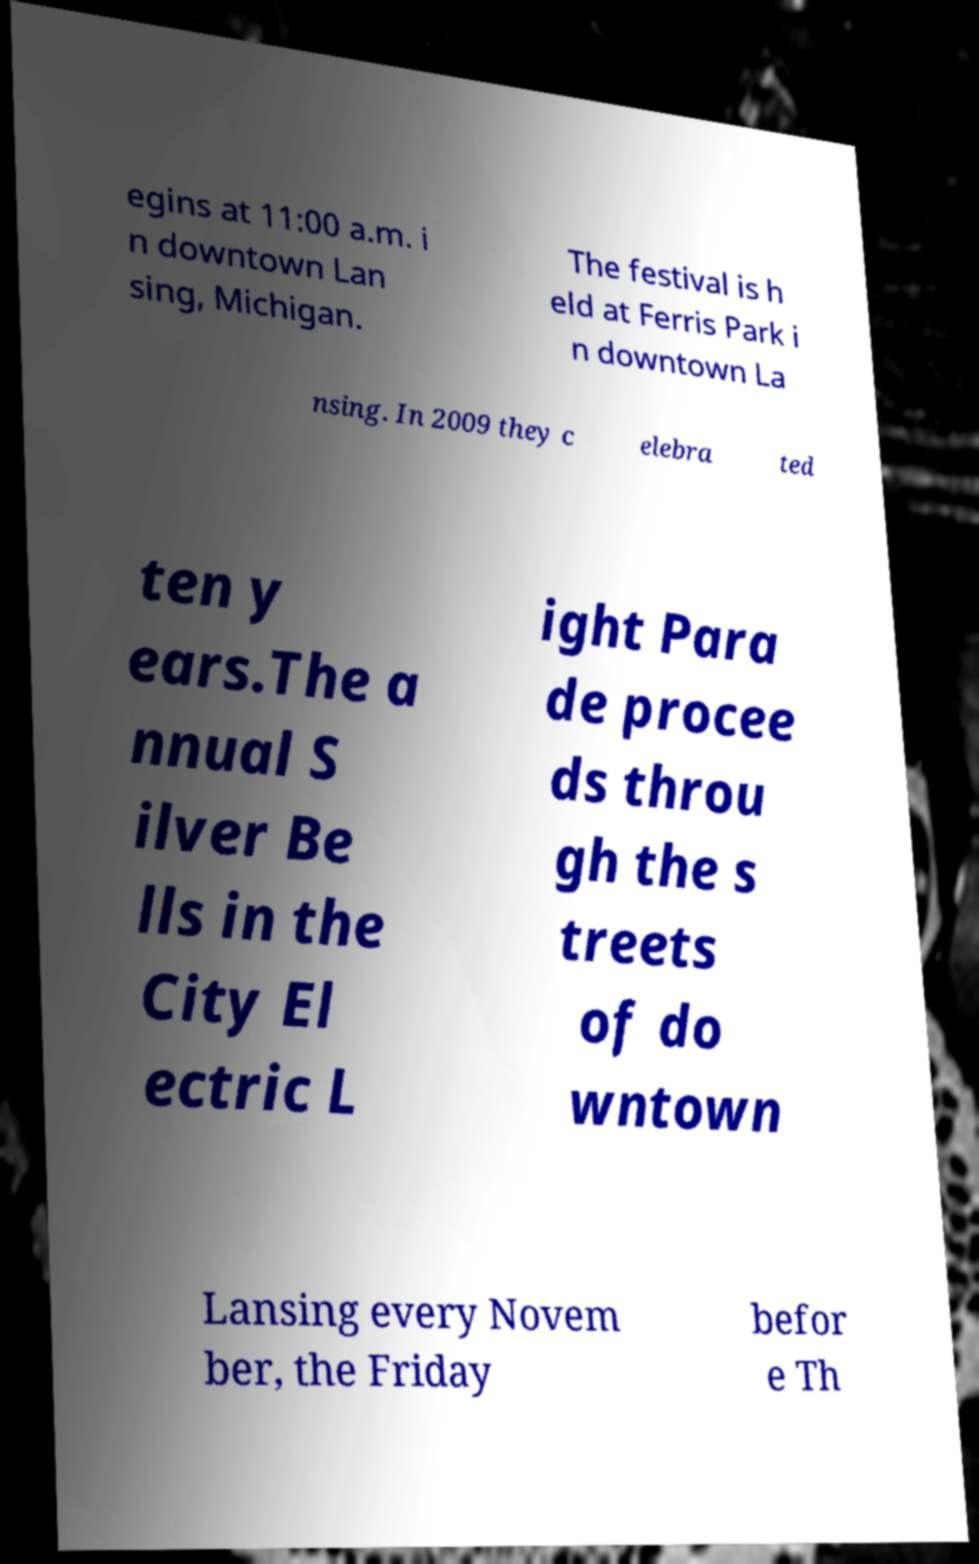Please read and relay the text visible in this image. What does it say? egins at 11:00 a.m. i n downtown Lan sing, Michigan. The festival is h eld at Ferris Park i n downtown La nsing. In 2009 they c elebra ted ten y ears.The a nnual S ilver Be lls in the City El ectric L ight Para de procee ds throu gh the s treets of do wntown Lansing every Novem ber, the Friday befor e Th 